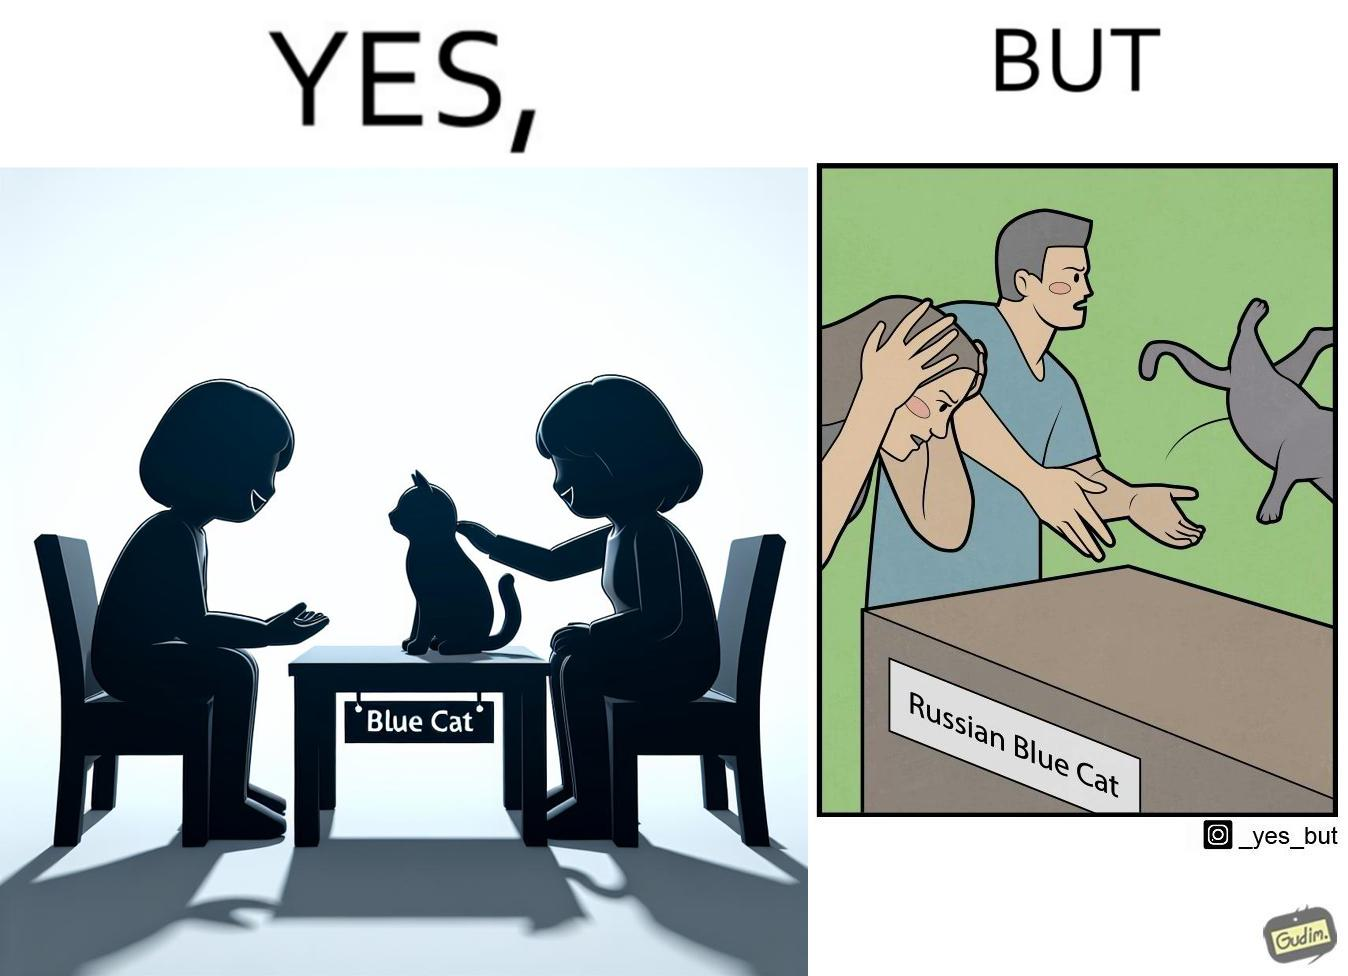Is there satirical content in this image? Yes, this image is satirical. 